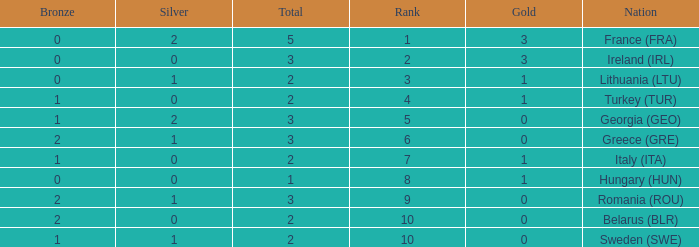What's the rank of Turkey (TUR) with a total more than 2? 0.0. 